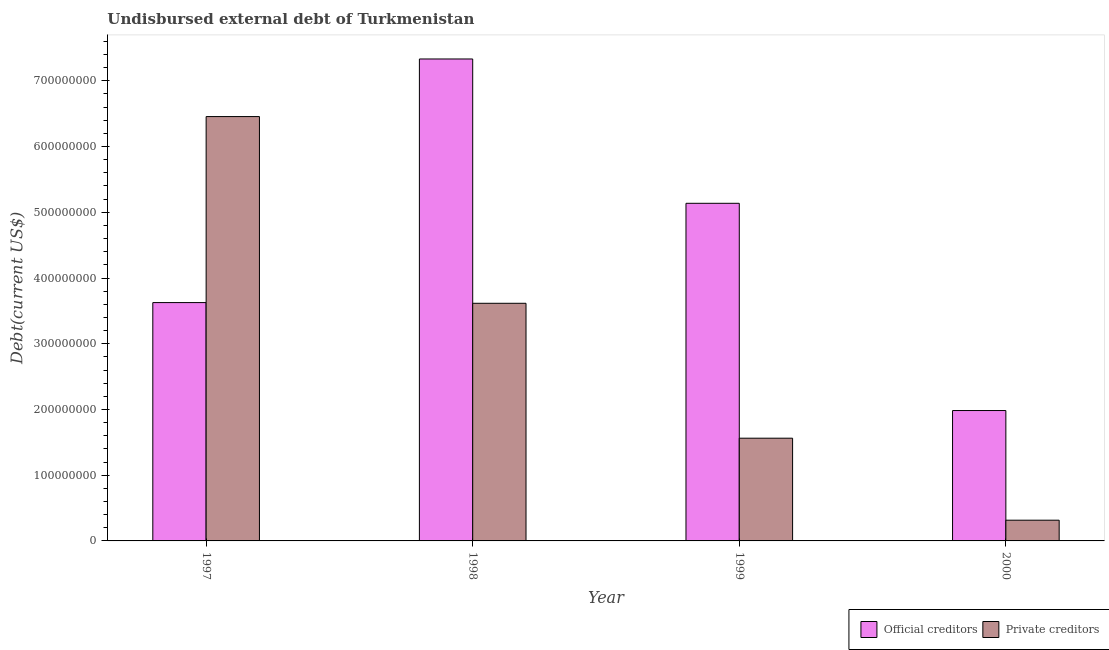How many different coloured bars are there?
Provide a succinct answer. 2. How many groups of bars are there?
Offer a terse response. 4. Are the number of bars per tick equal to the number of legend labels?
Your answer should be very brief. Yes. Are the number of bars on each tick of the X-axis equal?
Keep it short and to the point. Yes. How many bars are there on the 3rd tick from the right?
Offer a very short reply. 2. What is the label of the 4th group of bars from the left?
Keep it short and to the point. 2000. What is the undisbursed external debt of official creditors in 2000?
Provide a succinct answer. 1.98e+08. Across all years, what is the maximum undisbursed external debt of private creditors?
Give a very brief answer. 6.46e+08. Across all years, what is the minimum undisbursed external debt of official creditors?
Give a very brief answer. 1.98e+08. In which year was the undisbursed external debt of private creditors maximum?
Give a very brief answer. 1997. What is the total undisbursed external debt of private creditors in the graph?
Offer a very short reply. 1.19e+09. What is the difference between the undisbursed external debt of private creditors in 1997 and that in 1999?
Your answer should be compact. 4.89e+08. What is the difference between the undisbursed external debt of official creditors in 1997 and the undisbursed external debt of private creditors in 2000?
Offer a terse response. 1.64e+08. What is the average undisbursed external debt of private creditors per year?
Keep it short and to the point. 2.99e+08. What is the ratio of the undisbursed external debt of private creditors in 1997 to that in 1999?
Ensure brevity in your answer.  4.13. Is the undisbursed external debt of official creditors in 1999 less than that in 2000?
Make the answer very short. No. What is the difference between the highest and the second highest undisbursed external debt of private creditors?
Keep it short and to the point. 2.84e+08. What is the difference between the highest and the lowest undisbursed external debt of official creditors?
Give a very brief answer. 5.35e+08. Is the sum of the undisbursed external debt of private creditors in 1997 and 1999 greater than the maximum undisbursed external debt of official creditors across all years?
Keep it short and to the point. Yes. What does the 1st bar from the left in 2000 represents?
Your answer should be very brief. Official creditors. What does the 2nd bar from the right in 1999 represents?
Your answer should be very brief. Official creditors. Are all the bars in the graph horizontal?
Ensure brevity in your answer.  No. How many years are there in the graph?
Keep it short and to the point. 4. Are the values on the major ticks of Y-axis written in scientific E-notation?
Your answer should be compact. No. Does the graph contain any zero values?
Provide a short and direct response. No. Where does the legend appear in the graph?
Ensure brevity in your answer.  Bottom right. How are the legend labels stacked?
Give a very brief answer. Horizontal. What is the title of the graph?
Offer a very short reply. Undisbursed external debt of Turkmenistan. What is the label or title of the X-axis?
Provide a succinct answer. Year. What is the label or title of the Y-axis?
Offer a terse response. Debt(current US$). What is the Debt(current US$) in Official creditors in 1997?
Offer a very short reply. 3.63e+08. What is the Debt(current US$) of Private creditors in 1997?
Your response must be concise. 6.46e+08. What is the Debt(current US$) of Official creditors in 1998?
Provide a short and direct response. 7.33e+08. What is the Debt(current US$) of Private creditors in 1998?
Your answer should be compact. 3.62e+08. What is the Debt(current US$) of Official creditors in 1999?
Your answer should be very brief. 5.14e+08. What is the Debt(current US$) of Private creditors in 1999?
Keep it short and to the point. 1.56e+08. What is the Debt(current US$) of Official creditors in 2000?
Provide a succinct answer. 1.98e+08. What is the Debt(current US$) in Private creditors in 2000?
Ensure brevity in your answer.  3.15e+07. Across all years, what is the maximum Debt(current US$) in Official creditors?
Provide a succinct answer. 7.33e+08. Across all years, what is the maximum Debt(current US$) in Private creditors?
Offer a terse response. 6.46e+08. Across all years, what is the minimum Debt(current US$) in Official creditors?
Keep it short and to the point. 1.98e+08. Across all years, what is the minimum Debt(current US$) of Private creditors?
Keep it short and to the point. 3.15e+07. What is the total Debt(current US$) of Official creditors in the graph?
Provide a short and direct response. 1.81e+09. What is the total Debt(current US$) of Private creditors in the graph?
Give a very brief answer. 1.19e+09. What is the difference between the Debt(current US$) in Official creditors in 1997 and that in 1998?
Provide a succinct answer. -3.71e+08. What is the difference between the Debt(current US$) in Private creditors in 1997 and that in 1998?
Your answer should be very brief. 2.84e+08. What is the difference between the Debt(current US$) of Official creditors in 1997 and that in 1999?
Your answer should be very brief. -1.51e+08. What is the difference between the Debt(current US$) in Private creditors in 1997 and that in 1999?
Give a very brief answer. 4.89e+08. What is the difference between the Debt(current US$) in Official creditors in 1997 and that in 2000?
Ensure brevity in your answer.  1.64e+08. What is the difference between the Debt(current US$) of Private creditors in 1997 and that in 2000?
Provide a short and direct response. 6.14e+08. What is the difference between the Debt(current US$) in Official creditors in 1998 and that in 1999?
Your answer should be compact. 2.20e+08. What is the difference between the Debt(current US$) of Private creditors in 1998 and that in 1999?
Your response must be concise. 2.05e+08. What is the difference between the Debt(current US$) of Official creditors in 1998 and that in 2000?
Give a very brief answer. 5.35e+08. What is the difference between the Debt(current US$) of Private creditors in 1998 and that in 2000?
Your answer should be compact. 3.30e+08. What is the difference between the Debt(current US$) of Official creditors in 1999 and that in 2000?
Provide a short and direct response. 3.15e+08. What is the difference between the Debt(current US$) of Private creditors in 1999 and that in 2000?
Provide a short and direct response. 1.25e+08. What is the difference between the Debt(current US$) of Official creditors in 1997 and the Debt(current US$) of Private creditors in 1998?
Give a very brief answer. 1.08e+06. What is the difference between the Debt(current US$) of Official creditors in 1997 and the Debt(current US$) of Private creditors in 1999?
Offer a very short reply. 2.06e+08. What is the difference between the Debt(current US$) of Official creditors in 1997 and the Debt(current US$) of Private creditors in 2000?
Provide a short and direct response. 3.31e+08. What is the difference between the Debt(current US$) in Official creditors in 1998 and the Debt(current US$) in Private creditors in 1999?
Make the answer very short. 5.77e+08. What is the difference between the Debt(current US$) in Official creditors in 1998 and the Debt(current US$) in Private creditors in 2000?
Your response must be concise. 7.02e+08. What is the difference between the Debt(current US$) of Official creditors in 1999 and the Debt(current US$) of Private creditors in 2000?
Offer a very short reply. 4.82e+08. What is the average Debt(current US$) of Official creditors per year?
Ensure brevity in your answer.  4.52e+08. What is the average Debt(current US$) in Private creditors per year?
Offer a terse response. 2.99e+08. In the year 1997, what is the difference between the Debt(current US$) in Official creditors and Debt(current US$) in Private creditors?
Provide a succinct answer. -2.83e+08. In the year 1998, what is the difference between the Debt(current US$) in Official creditors and Debt(current US$) in Private creditors?
Give a very brief answer. 3.72e+08. In the year 1999, what is the difference between the Debt(current US$) in Official creditors and Debt(current US$) in Private creditors?
Your answer should be compact. 3.57e+08. In the year 2000, what is the difference between the Debt(current US$) in Official creditors and Debt(current US$) in Private creditors?
Provide a short and direct response. 1.67e+08. What is the ratio of the Debt(current US$) in Official creditors in 1997 to that in 1998?
Offer a very short reply. 0.49. What is the ratio of the Debt(current US$) of Private creditors in 1997 to that in 1998?
Your response must be concise. 1.79. What is the ratio of the Debt(current US$) of Official creditors in 1997 to that in 1999?
Offer a very short reply. 0.71. What is the ratio of the Debt(current US$) in Private creditors in 1997 to that in 1999?
Give a very brief answer. 4.13. What is the ratio of the Debt(current US$) in Official creditors in 1997 to that in 2000?
Your answer should be very brief. 1.83. What is the ratio of the Debt(current US$) of Private creditors in 1997 to that in 2000?
Provide a succinct answer. 20.47. What is the ratio of the Debt(current US$) in Official creditors in 1998 to that in 1999?
Your answer should be compact. 1.43. What is the ratio of the Debt(current US$) in Private creditors in 1998 to that in 1999?
Provide a succinct answer. 2.31. What is the ratio of the Debt(current US$) of Official creditors in 1998 to that in 2000?
Give a very brief answer. 3.7. What is the ratio of the Debt(current US$) in Private creditors in 1998 to that in 2000?
Keep it short and to the point. 11.47. What is the ratio of the Debt(current US$) of Official creditors in 1999 to that in 2000?
Your answer should be compact. 2.59. What is the ratio of the Debt(current US$) in Private creditors in 1999 to that in 2000?
Your response must be concise. 4.96. What is the difference between the highest and the second highest Debt(current US$) of Official creditors?
Give a very brief answer. 2.20e+08. What is the difference between the highest and the second highest Debt(current US$) of Private creditors?
Your answer should be very brief. 2.84e+08. What is the difference between the highest and the lowest Debt(current US$) in Official creditors?
Provide a succinct answer. 5.35e+08. What is the difference between the highest and the lowest Debt(current US$) in Private creditors?
Provide a succinct answer. 6.14e+08. 